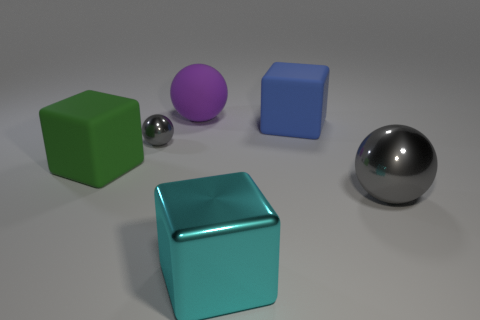Subtract all purple cylinders. How many gray spheres are left? 2 Subtract 1 balls. How many balls are left? 2 Add 3 purple cylinders. How many objects exist? 9 Subtract all red rubber blocks. Subtract all large cyan blocks. How many objects are left? 5 Add 5 big balls. How many big balls are left? 7 Add 4 small gray metallic objects. How many small gray metallic objects exist? 5 Subtract 0 green spheres. How many objects are left? 6 